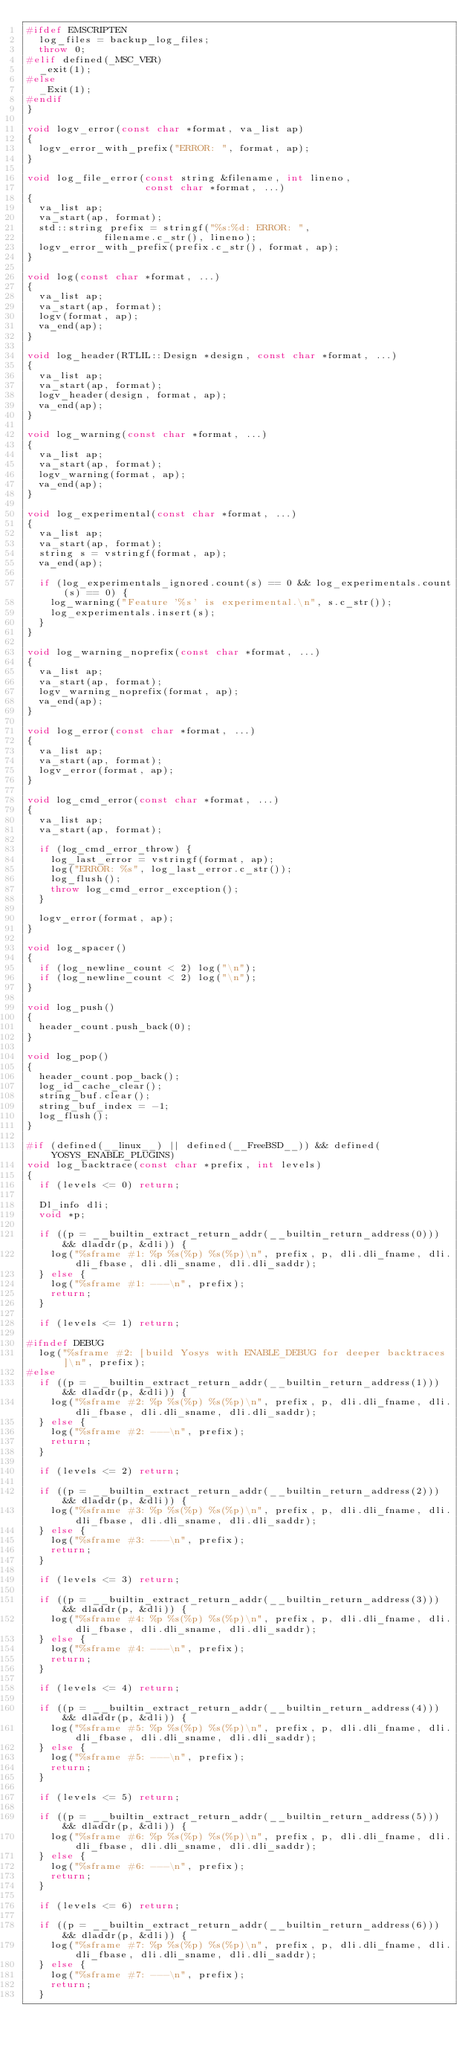Convert code to text. <code><loc_0><loc_0><loc_500><loc_500><_C++_>#ifdef EMSCRIPTEN
	log_files = backup_log_files;
	throw 0;
#elif defined(_MSC_VER)
	_exit(1);
#else
	_Exit(1);
#endif
}

void logv_error(const char *format, va_list ap)
{
	logv_error_with_prefix("ERROR: ", format, ap);
}

void log_file_error(const string &filename, int lineno,
                    const char *format, ...)
{
	va_list ap;
	va_start(ap, format);
	std::string prefix = stringf("%s:%d: ERROR: ",
				     filename.c_str(), lineno);
	logv_error_with_prefix(prefix.c_str(), format, ap);
}

void log(const char *format, ...)
{
	va_list ap;
	va_start(ap, format);
	logv(format, ap);
	va_end(ap);
}

void log_header(RTLIL::Design *design, const char *format, ...)
{
	va_list ap;
	va_start(ap, format);
	logv_header(design, format, ap);
	va_end(ap);
}

void log_warning(const char *format, ...)
{
	va_list ap;
	va_start(ap, format);
	logv_warning(format, ap);
	va_end(ap);
}

void log_experimental(const char *format, ...)
{
	va_list ap;
	va_start(ap, format);
	string s = vstringf(format, ap);
	va_end(ap);

	if (log_experimentals_ignored.count(s) == 0 && log_experimentals.count(s) == 0) {
		log_warning("Feature '%s' is experimental.\n", s.c_str());
		log_experimentals.insert(s);
	}
}

void log_warning_noprefix(const char *format, ...)
{
	va_list ap;
	va_start(ap, format);
	logv_warning_noprefix(format, ap);
	va_end(ap);
}

void log_error(const char *format, ...)
{
	va_list ap;
	va_start(ap, format);
	logv_error(format, ap);
}

void log_cmd_error(const char *format, ...)
{
	va_list ap;
	va_start(ap, format);

	if (log_cmd_error_throw) {
		log_last_error = vstringf(format, ap);
		log("ERROR: %s", log_last_error.c_str());
		log_flush();
		throw log_cmd_error_exception();
	}

	logv_error(format, ap);
}

void log_spacer()
{
	if (log_newline_count < 2) log("\n");
	if (log_newline_count < 2) log("\n");
}

void log_push()
{
	header_count.push_back(0);
}

void log_pop()
{
	header_count.pop_back();
	log_id_cache_clear();
	string_buf.clear();
	string_buf_index = -1;
	log_flush();
}

#if (defined(__linux__) || defined(__FreeBSD__)) && defined(YOSYS_ENABLE_PLUGINS)
void log_backtrace(const char *prefix, int levels)
{
	if (levels <= 0) return;

	Dl_info dli;
	void *p;

	if ((p = __builtin_extract_return_addr(__builtin_return_address(0))) && dladdr(p, &dli)) {
		log("%sframe #1: %p %s(%p) %s(%p)\n", prefix, p, dli.dli_fname, dli.dli_fbase, dli.dli_sname, dli.dli_saddr);
	} else {
		log("%sframe #1: ---\n", prefix);
		return;
	}

	if (levels <= 1) return;

#ifndef DEBUG
	log("%sframe #2: [build Yosys with ENABLE_DEBUG for deeper backtraces]\n", prefix);
#else
	if ((p = __builtin_extract_return_addr(__builtin_return_address(1))) && dladdr(p, &dli)) {
		log("%sframe #2: %p %s(%p) %s(%p)\n", prefix, p, dli.dli_fname, dli.dli_fbase, dli.dli_sname, dli.dli_saddr);
	} else {
		log("%sframe #2: ---\n", prefix);
		return;
	}

	if (levels <= 2) return;

	if ((p = __builtin_extract_return_addr(__builtin_return_address(2))) && dladdr(p, &dli)) {
		log("%sframe #3: %p %s(%p) %s(%p)\n", prefix, p, dli.dli_fname, dli.dli_fbase, dli.dli_sname, dli.dli_saddr);
	} else {
		log("%sframe #3: ---\n", prefix);
		return;
	}

	if (levels <= 3) return;

	if ((p = __builtin_extract_return_addr(__builtin_return_address(3))) && dladdr(p, &dli)) {
		log("%sframe #4: %p %s(%p) %s(%p)\n", prefix, p, dli.dli_fname, dli.dli_fbase, dli.dli_sname, dli.dli_saddr);
	} else {
		log("%sframe #4: ---\n", prefix);
		return;
	}

	if (levels <= 4) return;

	if ((p = __builtin_extract_return_addr(__builtin_return_address(4))) && dladdr(p, &dli)) {
		log("%sframe #5: %p %s(%p) %s(%p)\n", prefix, p, dli.dli_fname, dli.dli_fbase, dli.dli_sname, dli.dli_saddr);
	} else {
		log("%sframe #5: ---\n", prefix);
		return;
	}

	if (levels <= 5) return;

	if ((p = __builtin_extract_return_addr(__builtin_return_address(5))) && dladdr(p, &dli)) {
		log("%sframe #6: %p %s(%p) %s(%p)\n", prefix, p, dli.dli_fname, dli.dli_fbase, dli.dli_sname, dli.dli_saddr);
	} else {
		log("%sframe #6: ---\n", prefix);
		return;
	}

	if (levels <= 6) return;

	if ((p = __builtin_extract_return_addr(__builtin_return_address(6))) && dladdr(p, &dli)) {
		log("%sframe #7: %p %s(%p) %s(%p)\n", prefix, p, dli.dli_fname, dli.dli_fbase, dli.dli_sname, dli.dli_saddr);
	} else {
		log("%sframe #7: ---\n", prefix);
		return;
	}
</code> 